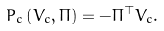Convert formula to latex. <formula><loc_0><loc_0><loc_500><loc_500>P _ { c } \left ( V _ { c } , \Pi \right ) = - \Pi ^ { \top } V _ { c } .</formula> 